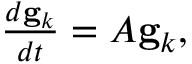<formula> <loc_0><loc_0><loc_500><loc_500>\begin{array} { r } { \frac { d g _ { k } } { d t } = A g _ { k } , } \end{array}</formula> 